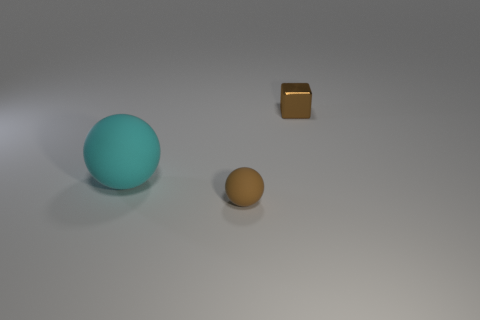Add 1 large matte things. How many objects exist? 4 Subtract all spheres. How many objects are left? 1 Subtract all small red shiny objects. Subtract all big spheres. How many objects are left? 2 Add 3 tiny matte things. How many tiny matte things are left? 4 Add 2 gray cylinders. How many gray cylinders exist? 2 Subtract 0 gray cylinders. How many objects are left? 3 